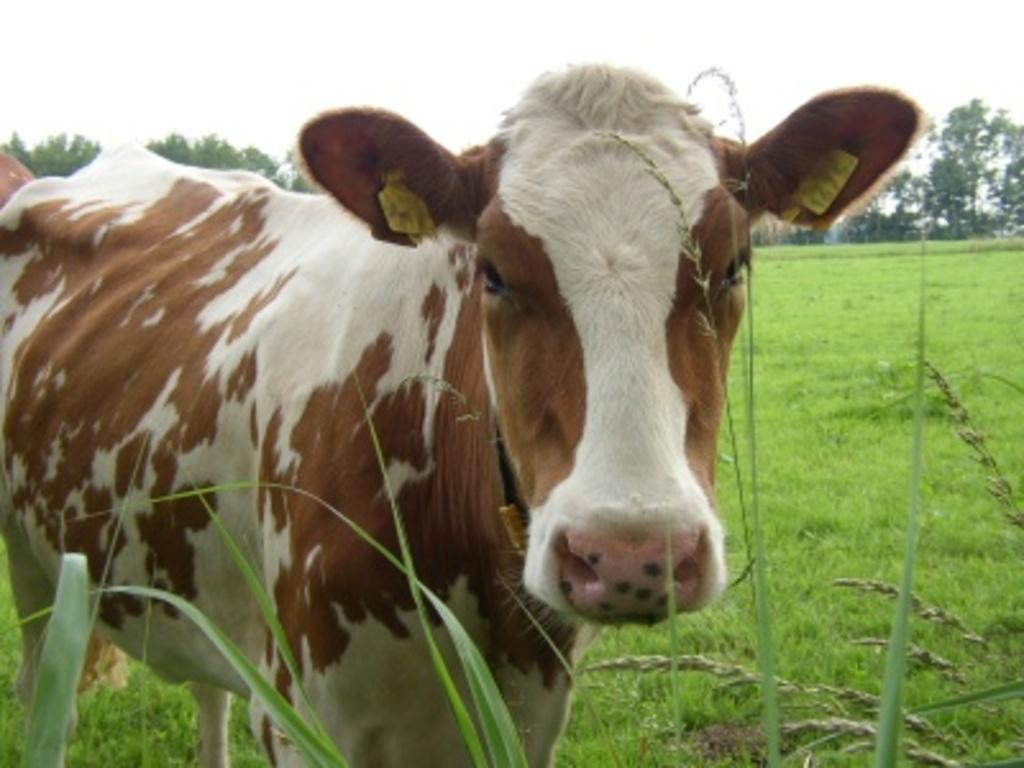What type of animal can be seen in the image? There is an animal in the image, but its specific type cannot be determined from the provided facts. Can you describe the color of the animal? The animal is white and brown in color. Where is the animal located in the image? The animal is on the grass. What can be seen in the background of the image? There are many trees and the sky visible in the background of the image. What type of seed is the animal planting in the image? There is no indication in the image that the animal is planting seeds, and therefore no such activity can be observed. 